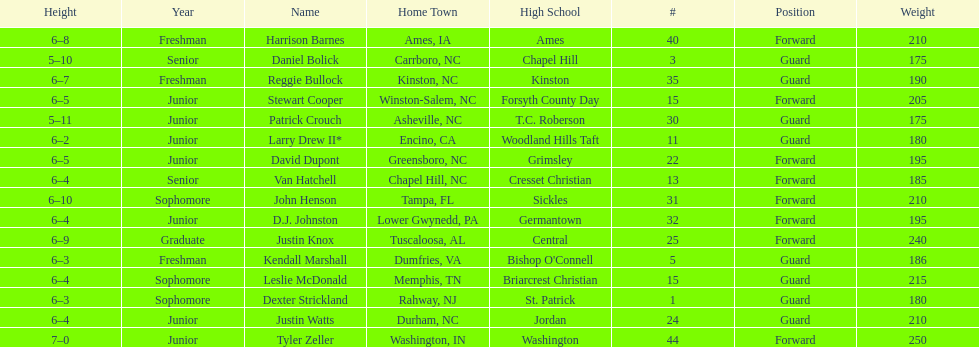How many players have a hometown in north carolina (nc)? 7. 